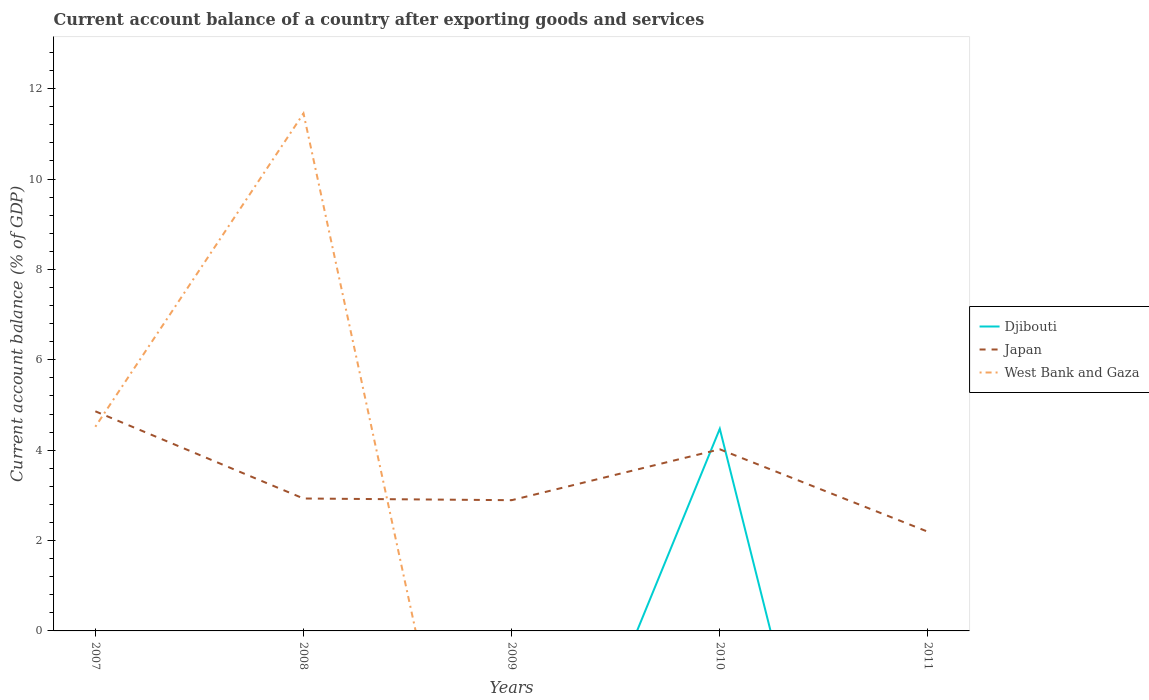How many different coloured lines are there?
Provide a short and direct response. 3. Across all years, what is the maximum account balance in Japan?
Give a very brief answer. 2.19. What is the total account balance in Japan in the graph?
Offer a very short reply. 0.74. What is the difference between the highest and the second highest account balance in Japan?
Offer a very short reply. 2.67. How many lines are there?
Provide a succinct answer. 3. Does the graph contain grids?
Your answer should be very brief. No. How are the legend labels stacked?
Provide a succinct answer. Vertical. What is the title of the graph?
Your answer should be very brief. Current account balance of a country after exporting goods and services. Does "Hungary" appear as one of the legend labels in the graph?
Give a very brief answer. No. What is the label or title of the Y-axis?
Offer a terse response. Current account balance (% of GDP). What is the Current account balance (% of GDP) of Japan in 2007?
Keep it short and to the point. 4.86. What is the Current account balance (% of GDP) of West Bank and Gaza in 2007?
Ensure brevity in your answer.  4.52. What is the Current account balance (% of GDP) in Japan in 2008?
Provide a short and direct response. 2.93. What is the Current account balance (% of GDP) in West Bank and Gaza in 2008?
Make the answer very short. 11.45. What is the Current account balance (% of GDP) in Japan in 2009?
Make the answer very short. 2.89. What is the Current account balance (% of GDP) in Djibouti in 2010?
Keep it short and to the point. 4.47. What is the Current account balance (% of GDP) of Japan in 2010?
Offer a very short reply. 4.02. What is the Current account balance (% of GDP) of West Bank and Gaza in 2010?
Ensure brevity in your answer.  0. What is the Current account balance (% of GDP) in Djibouti in 2011?
Keep it short and to the point. 0. What is the Current account balance (% of GDP) of Japan in 2011?
Provide a succinct answer. 2.19. Across all years, what is the maximum Current account balance (% of GDP) in Djibouti?
Ensure brevity in your answer.  4.47. Across all years, what is the maximum Current account balance (% of GDP) in Japan?
Provide a succinct answer. 4.86. Across all years, what is the maximum Current account balance (% of GDP) in West Bank and Gaza?
Give a very brief answer. 11.45. Across all years, what is the minimum Current account balance (% of GDP) of Djibouti?
Provide a short and direct response. 0. Across all years, what is the minimum Current account balance (% of GDP) in Japan?
Make the answer very short. 2.19. Across all years, what is the minimum Current account balance (% of GDP) of West Bank and Gaza?
Offer a very short reply. 0. What is the total Current account balance (% of GDP) in Djibouti in the graph?
Keep it short and to the point. 4.47. What is the total Current account balance (% of GDP) in Japan in the graph?
Provide a succinct answer. 16.9. What is the total Current account balance (% of GDP) of West Bank and Gaza in the graph?
Provide a succinct answer. 15.97. What is the difference between the Current account balance (% of GDP) in Japan in 2007 and that in 2008?
Offer a very short reply. 1.93. What is the difference between the Current account balance (% of GDP) of West Bank and Gaza in 2007 and that in 2008?
Offer a terse response. -6.93. What is the difference between the Current account balance (% of GDP) in Japan in 2007 and that in 2009?
Offer a very short reply. 1.97. What is the difference between the Current account balance (% of GDP) of Japan in 2007 and that in 2010?
Offer a very short reply. 0.84. What is the difference between the Current account balance (% of GDP) of Japan in 2007 and that in 2011?
Keep it short and to the point. 2.67. What is the difference between the Current account balance (% of GDP) in Japan in 2008 and that in 2009?
Offer a terse response. 0.04. What is the difference between the Current account balance (% of GDP) in Japan in 2008 and that in 2010?
Your answer should be compact. -1.09. What is the difference between the Current account balance (% of GDP) in Japan in 2008 and that in 2011?
Make the answer very short. 0.74. What is the difference between the Current account balance (% of GDP) in Japan in 2009 and that in 2010?
Your response must be concise. -1.13. What is the difference between the Current account balance (% of GDP) in Japan in 2009 and that in 2011?
Give a very brief answer. 0.7. What is the difference between the Current account balance (% of GDP) in Japan in 2010 and that in 2011?
Give a very brief answer. 1.83. What is the difference between the Current account balance (% of GDP) of Japan in 2007 and the Current account balance (% of GDP) of West Bank and Gaza in 2008?
Make the answer very short. -6.59. What is the difference between the Current account balance (% of GDP) of Djibouti in 2010 and the Current account balance (% of GDP) of Japan in 2011?
Offer a terse response. 2.28. What is the average Current account balance (% of GDP) of Djibouti per year?
Give a very brief answer. 0.89. What is the average Current account balance (% of GDP) of Japan per year?
Ensure brevity in your answer.  3.38. What is the average Current account balance (% of GDP) in West Bank and Gaza per year?
Ensure brevity in your answer.  3.19. In the year 2007, what is the difference between the Current account balance (% of GDP) in Japan and Current account balance (% of GDP) in West Bank and Gaza?
Provide a short and direct response. 0.34. In the year 2008, what is the difference between the Current account balance (% of GDP) in Japan and Current account balance (% of GDP) in West Bank and Gaza?
Your answer should be very brief. -8.52. In the year 2010, what is the difference between the Current account balance (% of GDP) of Djibouti and Current account balance (% of GDP) of Japan?
Your answer should be compact. 0.45. What is the ratio of the Current account balance (% of GDP) of Japan in 2007 to that in 2008?
Keep it short and to the point. 1.66. What is the ratio of the Current account balance (% of GDP) of West Bank and Gaza in 2007 to that in 2008?
Keep it short and to the point. 0.39. What is the ratio of the Current account balance (% of GDP) in Japan in 2007 to that in 2009?
Ensure brevity in your answer.  1.68. What is the ratio of the Current account balance (% of GDP) in Japan in 2007 to that in 2010?
Give a very brief answer. 1.21. What is the ratio of the Current account balance (% of GDP) of Japan in 2007 to that in 2011?
Keep it short and to the point. 2.21. What is the ratio of the Current account balance (% of GDP) in Japan in 2008 to that in 2009?
Your answer should be compact. 1.01. What is the ratio of the Current account balance (% of GDP) in Japan in 2008 to that in 2010?
Keep it short and to the point. 0.73. What is the ratio of the Current account balance (% of GDP) in Japan in 2008 to that in 2011?
Ensure brevity in your answer.  1.34. What is the ratio of the Current account balance (% of GDP) of Japan in 2009 to that in 2010?
Provide a short and direct response. 0.72. What is the ratio of the Current account balance (% of GDP) in Japan in 2009 to that in 2011?
Give a very brief answer. 1.32. What is the ratio of the Current account balance (% of GDP) of Japan in 2010 to that in 2011?
Make the answer very short. 1.83. What is the difference between the highest and the second highest Current account balance (% of GDP) in Japan?
Give a very brief answer. 0.84. What is the difference between the highest and the lowest Current account balance (% of GDP) of Djibouti?
Your answer should be very brief. 4.47. What is the difference between the highest and the lowest Current account balance (% of GDP) in Japan?
Make the answer very short. 2.67. What is the difference between the highest and the lowest Current account balance (% of GDP) of West Bank and Gaza?
Give a very brief answer. 11.45. 